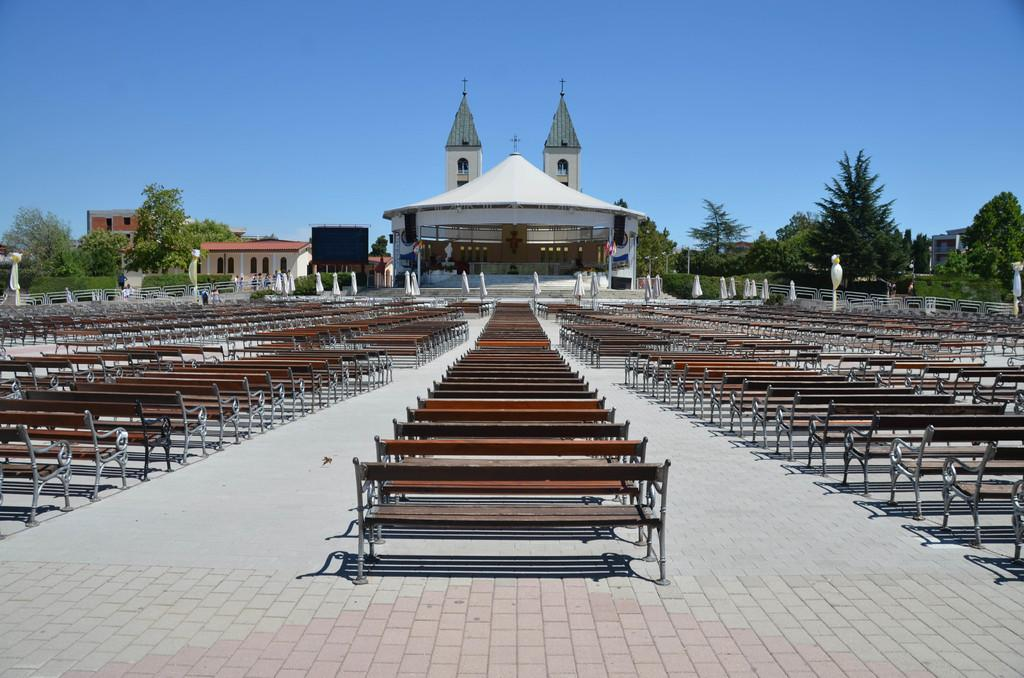What type of seating is visible in the image? There are many benches in the image. What type of structure can be seen in the image? There is a building in the image. What type of vegetation is present in the image? There are trees in the image. What type of barrier is visible in the image? There is a fence in the image. What type of vertical structure is present in the image? There is a pole in the image. What type of openings are present on the building in the image? There are windows on the building in the image. What type of surface is visible in the image? There is a floor visible in the image. What is the color of the sky in the image? The sky is pale blue in the image. What type of symbol is present in the image? There is a cross symbol in the image. What type of beast is present in the image? There is no beast present in the image. What type of committee is meeting in the image? There is no committee meeting in the image. What type of stick is being used to stir the cross symbol in the image? There is no stick present in the image, and the cross symbol is not being stirred. 